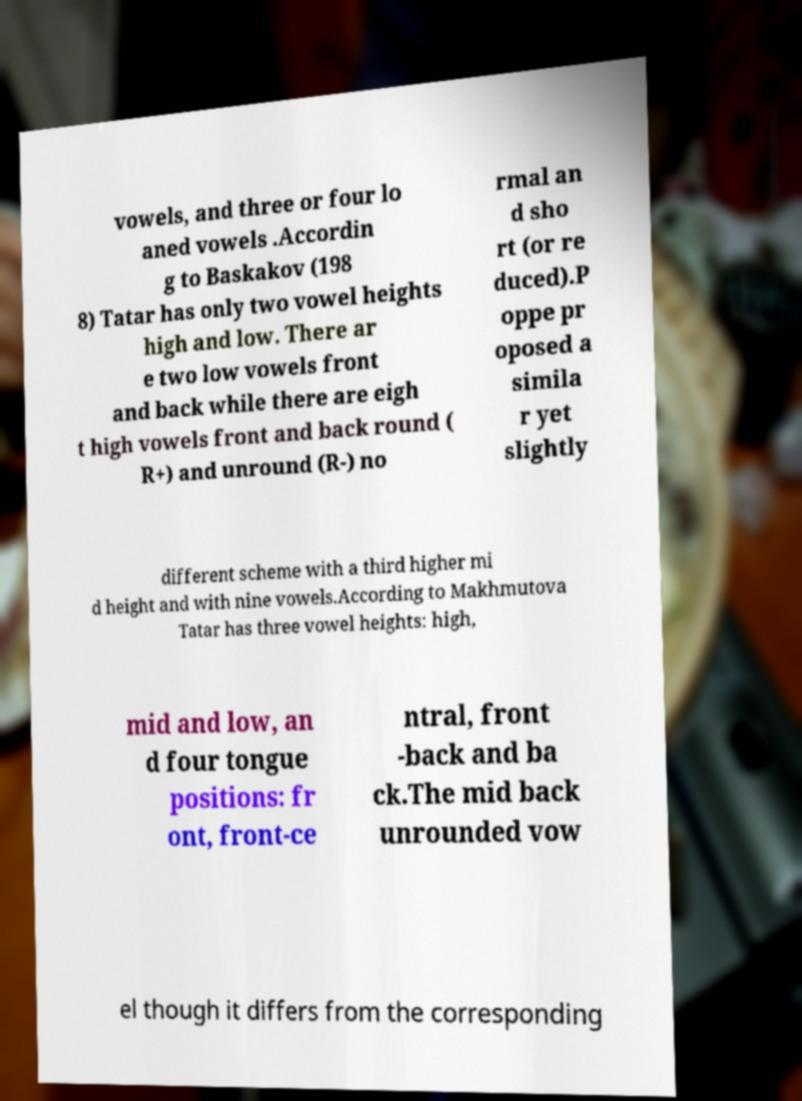Can you accurately transcribe the text from the provided image for me? vowels, and three or four lo aned vowels .Accordin g to Baskakov (198 8) Tatar has only two vowel heights high and low. There ar e two low vowels front and back while there are eigh t high vowels front and back round ( R+) and unround (R-) no rmal an d sho rt (or re duced).P oppe pr oposed a simila r yet slightly different scheme with a third higher mi d height and with nine vowels.According to Makhmutova Tatar has three vowel heights: high, mid and low, an d four tongue positions: fr ont, front-ce ntral, front -back and ba ck.The mid back unrounded vow el though it differs from the corresponding 